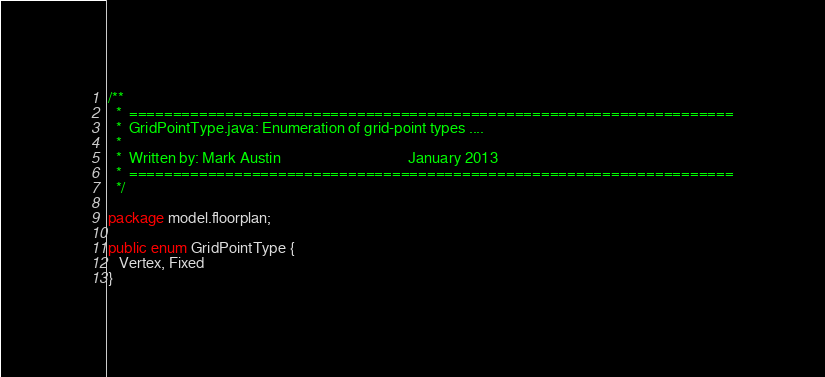Convert code to text. <code><loc_0><loc_0><loc_500><loc_500><_Java_>/**
  *  =====================================================================
  *  GridPointType.java: Enumeration of grid-point types ....
  * 
  *  Written by: Mark Austin                                  January 2013
  *  =====================================================================
  */

package model.floorplan;

public enum GridPointType {
   Vertex, Fixed
}
</code> 